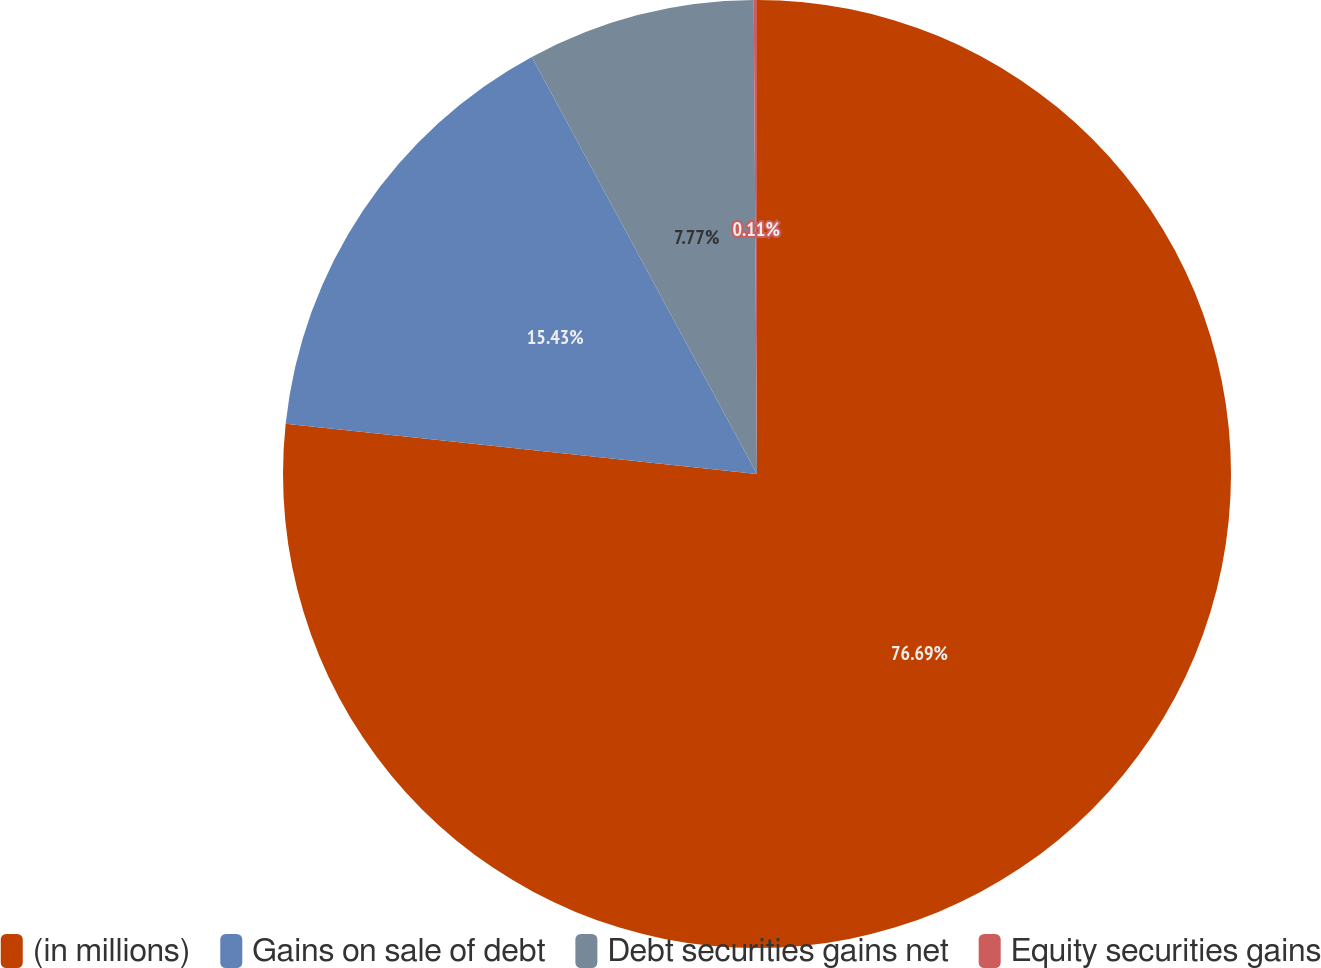<chart> <loc_0><loc_0><loc_500><loc_500><pie_chart><fcel>(in millions)<fcel>Gains on sale of debt<fcel>Debt securities gains net<fcel>Equity securities gains<nl><fcel>76.69%<fcel>15.43%<fcel>7.77%<fcel>0.11%<nl></chart> 